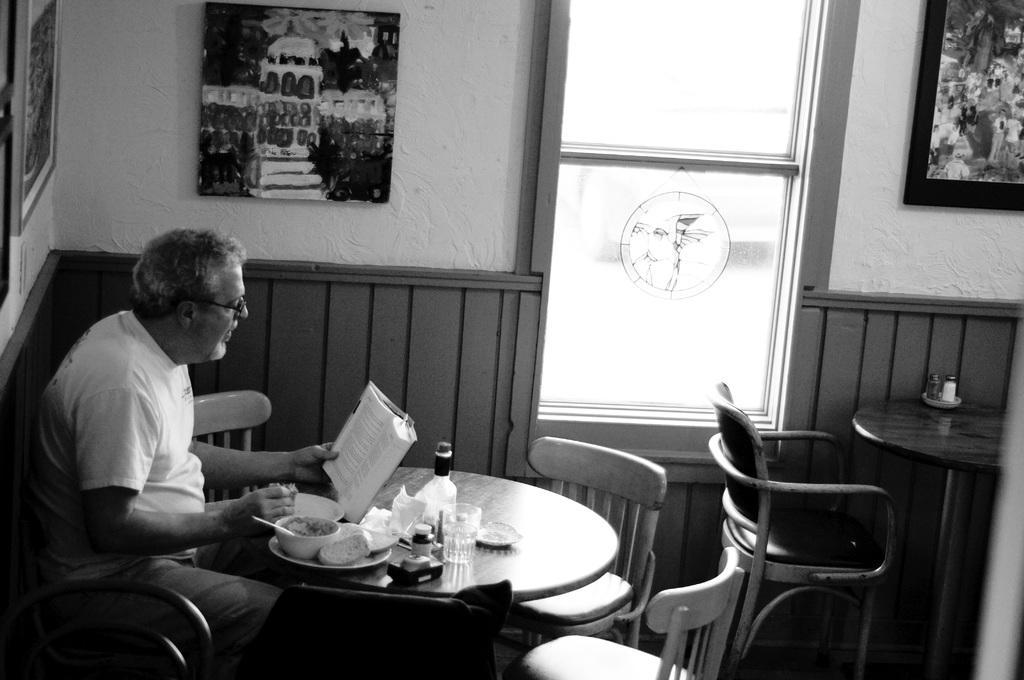In one or two sentences, can you explain what this image depicts? In this picture we can see a man, he is seated on the chair, and he is holding a book, in front of him we can see food, glass and a bottle on the table, and we can see few paintings on the wall. 